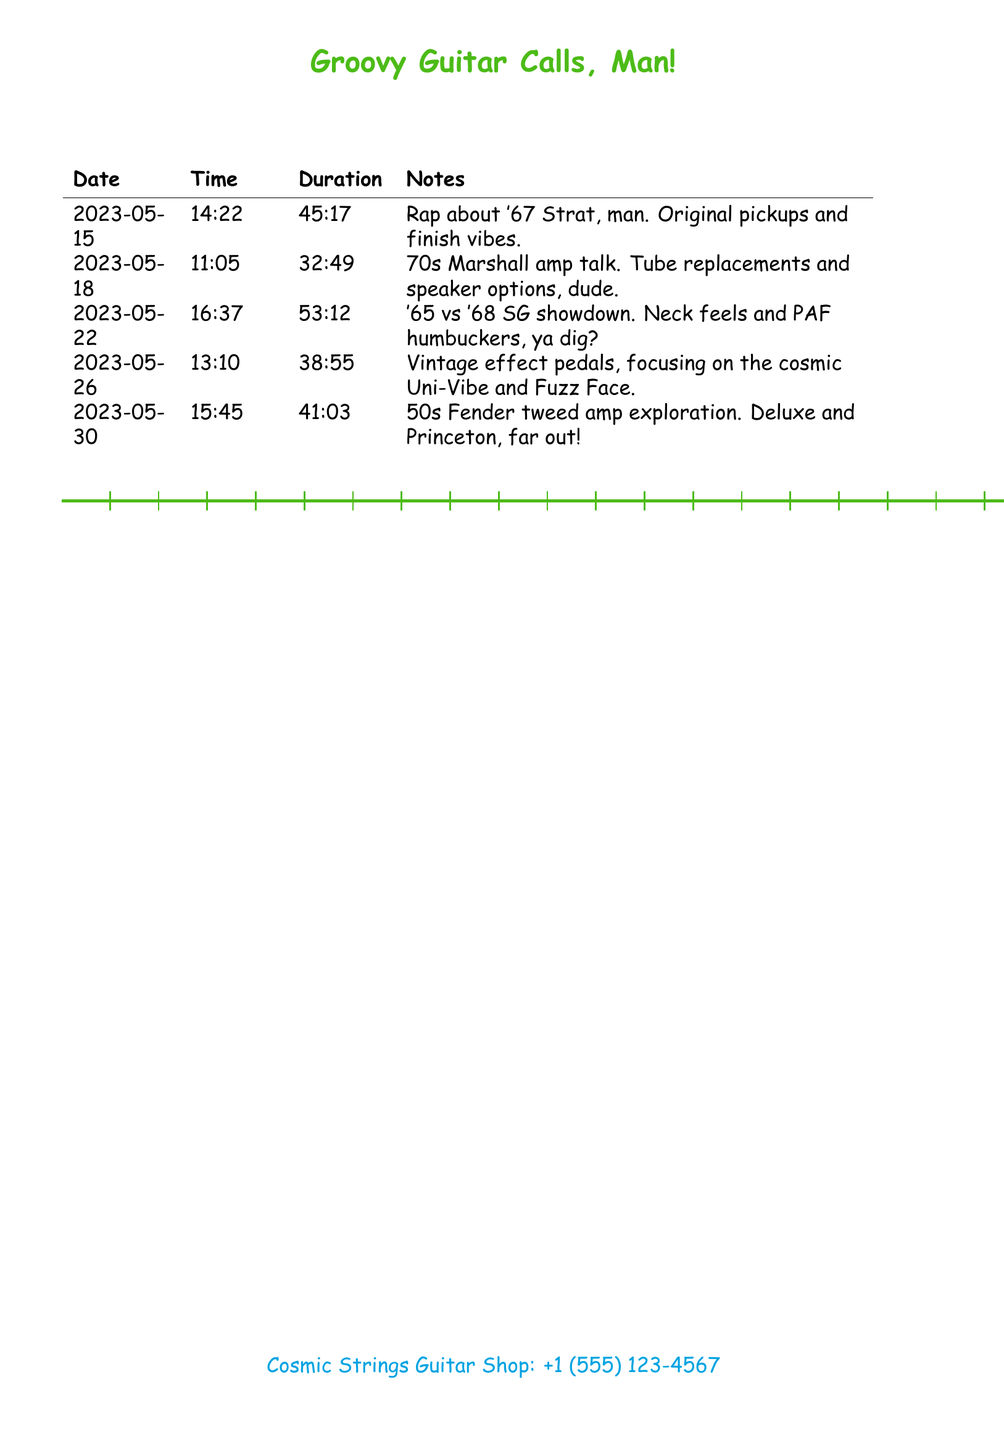What is the name of the music store? The document lists the name of the music store as "Cosmic Strings Guitar Shop."
Answer: Cosmic Strings Guitar Shop How many calls are documented? There are a total of five calls listed in the call log.
Answer: 5 What was discussed on May 26? The notes mention a focus on vintage effect pedals.
Answer: Vintage effect pedals What is the duration of the call on May 30? The duration recorded for the May 30 call is 41 minutes and 3 seconds.
Answer: 41:03 Which amplifier was discussed on May 18? The call on May 18 is about a 70s Marshall amp.
Answer: 70s Marshall amp Which guitar model was compared during the conversation on May 22? The document indicates a comparison between the '65 and '68 SG models.
Answer: '65 vs '68 SG What type of pickups were talked about on May 15? The conversation noted original pickups as part of the discussion.
Answer: original pickups Which two Fender amplifiers were explored on May 30? The document mentions both Deluxe and Princeton Fender amplifiers.
Answer: Deluxe and Princeton How long was the longest conversation? The longest conversation recorded was 53 minutes and 12 seconds.
Answer: 53:12 